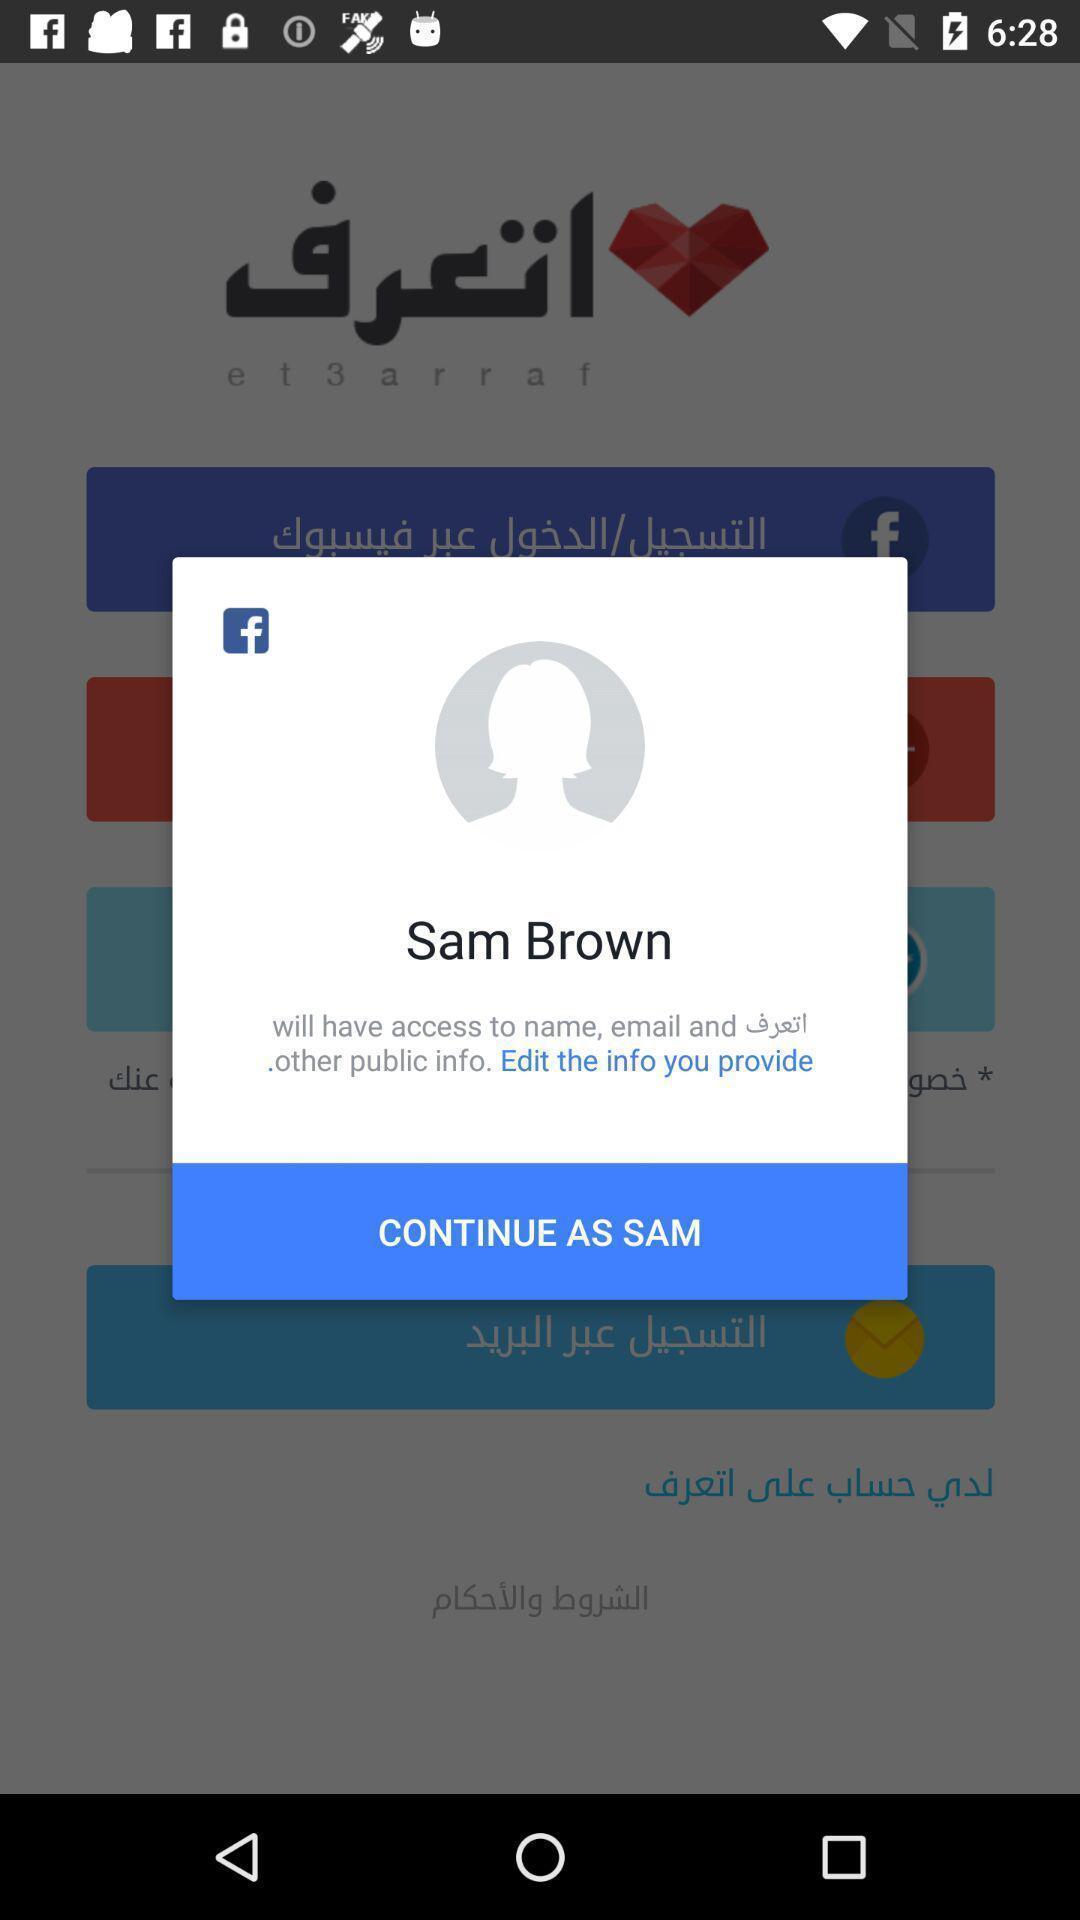Tell me what you see in this picture. Popup showing information about profile and continue option. 